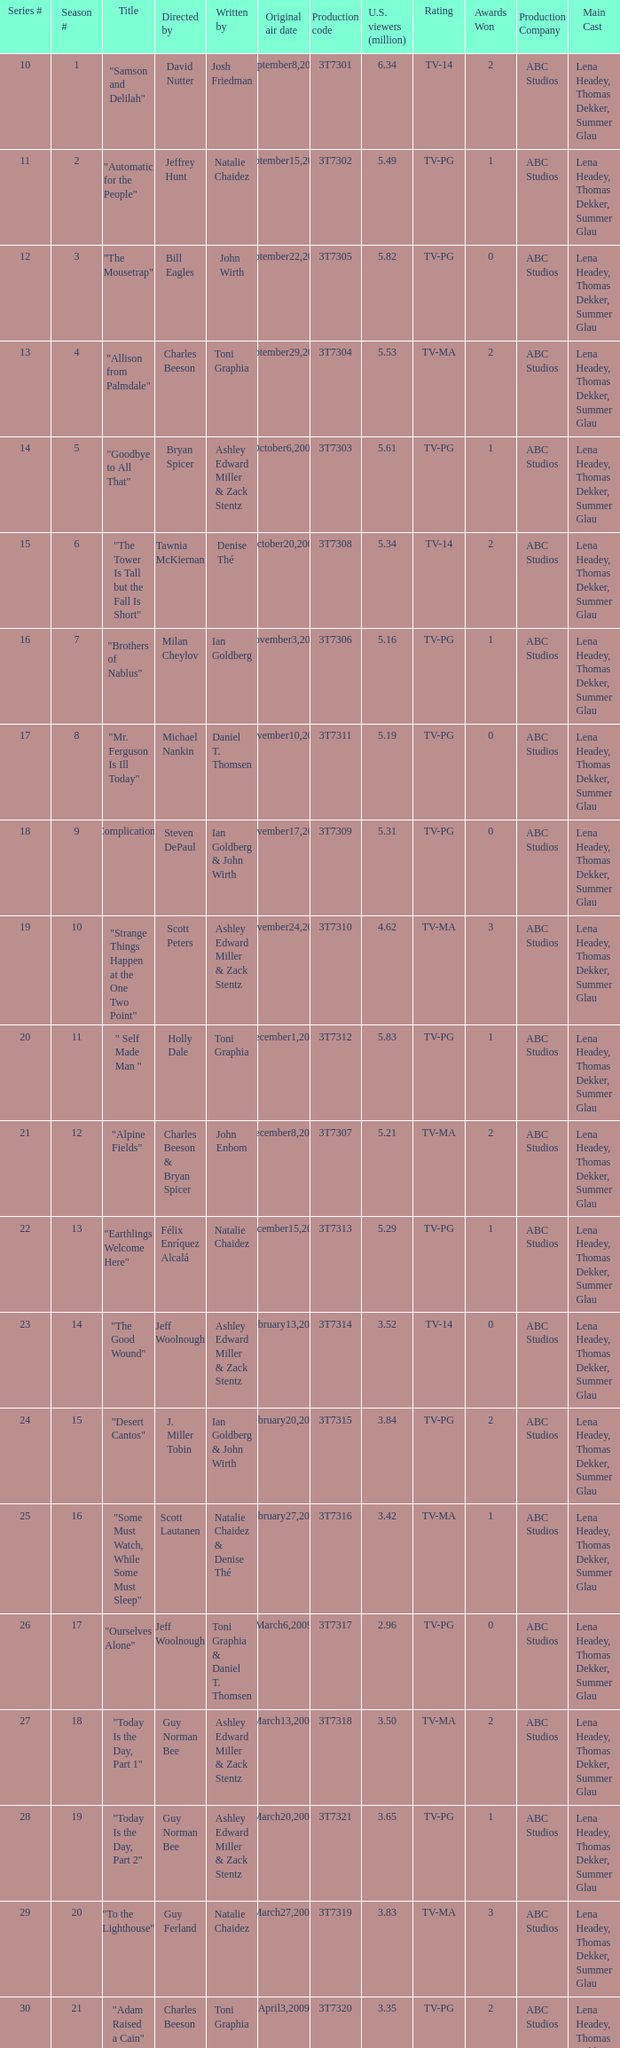How many viewers did the episode directed by David Nutter draw in? 6.34. 